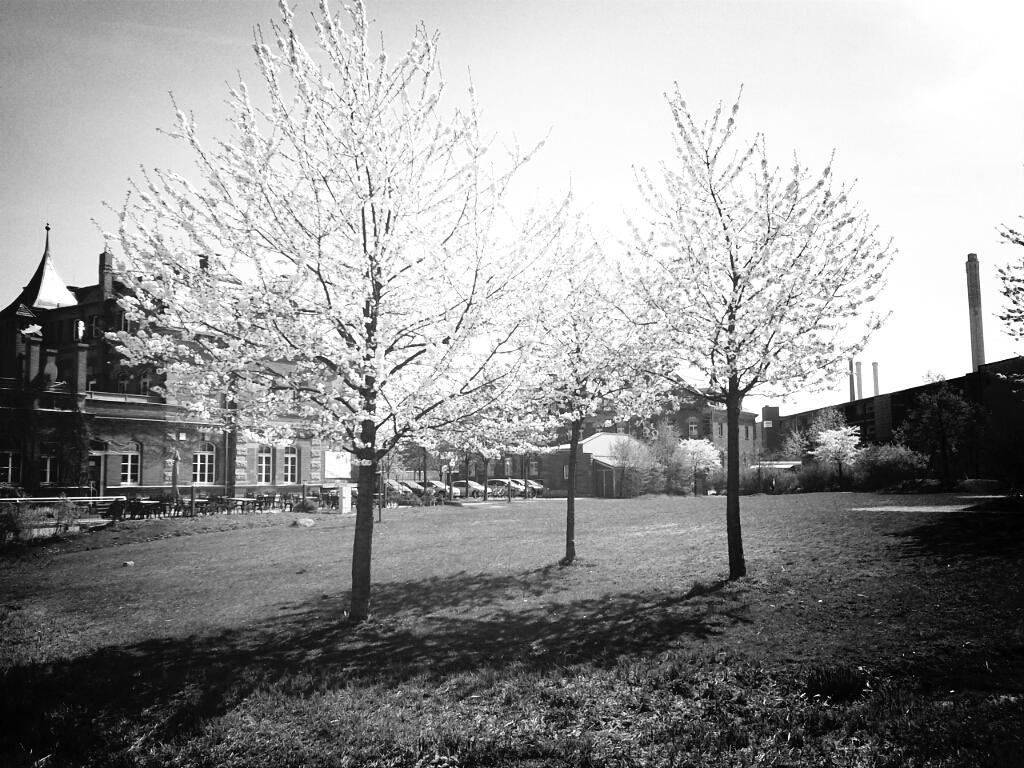Can you describe this image briefly? In the foreground of this black and white image, there are trees. In the background, there are few buildings, trees, vehicles, it seems like benches, grassland and the sky. 